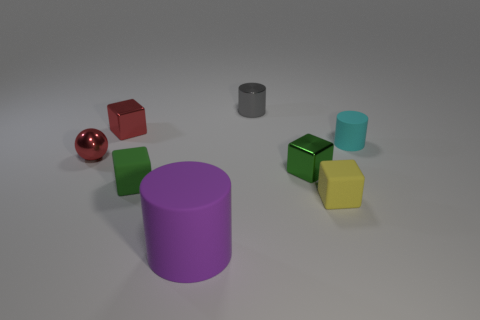Subtract all blue blocks. Subtract all cyan cylinders. How many blocks are left? 4 Add 1 cyan things. How many objects exist? 9 Subtract all cylinders. How many objects are left? 5 Add 2 gray objects. How many gray objects exist? 3 Subtract 0 purple blocks. How many objects are left? 8 Subtract all brown rubber cylinders. Subtract all tiny green objects. How many objects are left? 6 Add 7 cyan rubber cylinders. How many cyan rubber cylinders are left? 8 